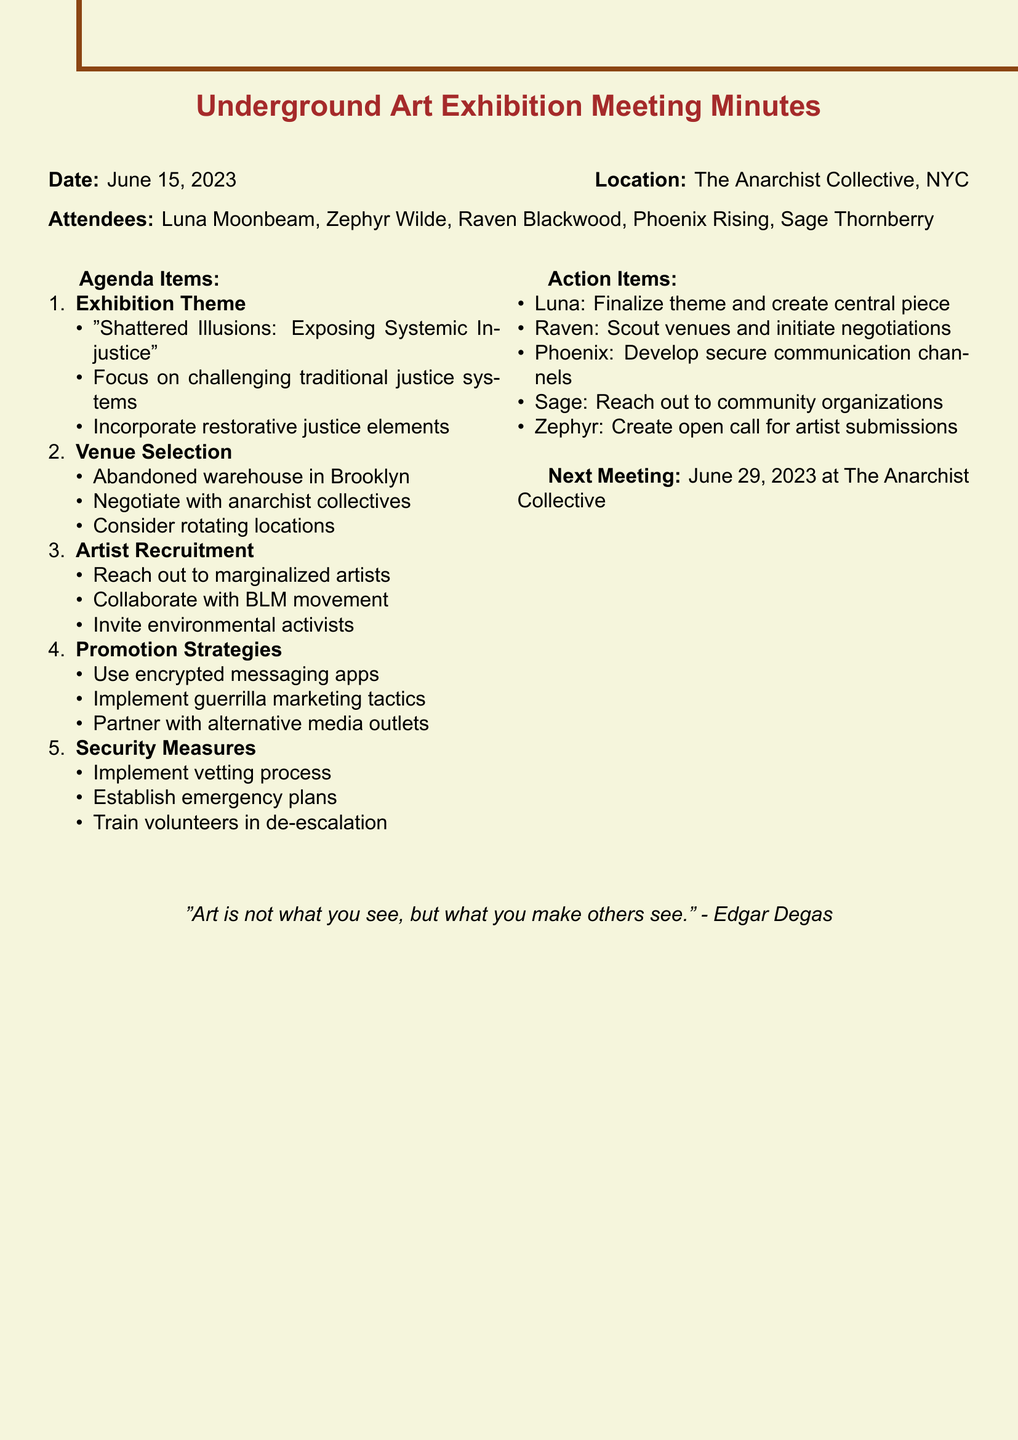What is the title of the meeting? The title is stated at the beginning of the document as "Brainstorming Session: Underground Art Exhibition - Challenging Societal Norms."
Answer: Underground Art Exhibition - Challenging Societal Norms Who is the Lead Artist? The attendee list includes the Lead Artist's name, which is listed first.
Answer: Luna Moonbeam What is the proposed theme for the exhibition? The agenda item regarding the theme gives a specific title for the proposed theme.
Answer: Shattered Illusions: Exposing Systemic Injustice Where is the meeting scheduled to take place next? The next meeting location is specified in the document.
Answer: The Anarchist Collective What is one of the Promotion Strategies mentioned? The notes on promotion strategies include multiple tactics, and only one needs to be cited.
Answer: Use encrypted messaging apps How many attendees were present at the meeting? The document lists the names of attendees, which allow for a count to be easily made.
Answer: Five What security measure was proposed? One of the security measures is highlighted in the notes under security measures.
Answer: Implement a vetting process Which community organization is specifically mentioned for collaboration? The agenda item on artist recruitment mentions a specific movement for collaboration.
Answer: Black Lives Matter Who is responsible for scouting venues? The action items section assigns specific tasks to attendees, pointing out the person responsible for this task.
Answer: Raven What is the date of the next meeting? The document lists the date explicitly under the next meeting section.
Answer: June 29, 2023 